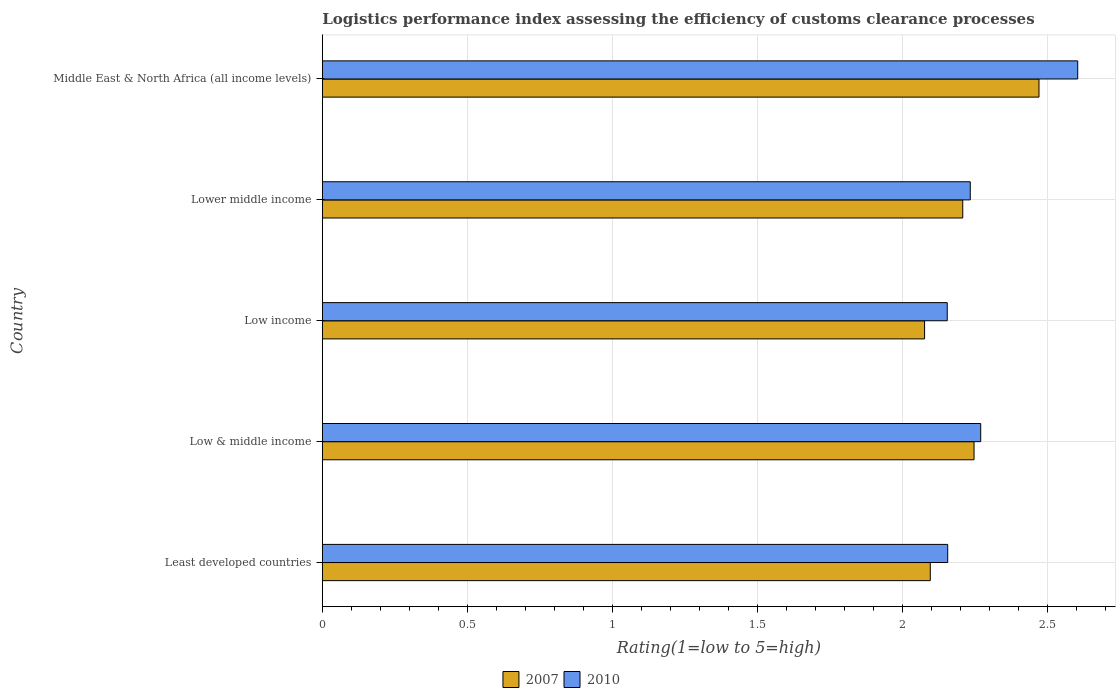How many groups of bars are there?
Offer a terse response. 5. Are the number of bars per tick equal to the number of legend labels?
Keep it short and to the point. Yes. How many bars are there on the 4th tick from the top?
Provide a succinct answer. 2. How many bars are there on the 3rd tick from the bottom?
Offer a terse response. 2. What is the label of the 2nd group of bars from the top?
Provide a succinct answer. Lower middle income. In how many cases, is the number of bars for a given country not equal to the number of legend labels?
Provide a short and direct response. 0. What is the Logistic performance index in 2010 in Low income?
Provide a short and direct response. 2.15. Across all countries, what is the maximum Logistic performance index in 2007?
Provide a short and direct response. 2.47. Across all countries, what is the minimum Logistic performance index in 2007?
Keep it short and to the point. 2.08. In which country was the Logistic performance index in 2007 maximum?
Offer a terse response. Middle East & North Africa (all income levels). In which country was the Logistic performance index in 2010 minimum?
Provide a succinct answer. Low income. What is the total Logistic performance index in 2010 in the graph?
Keep it short and to the point. 11.42. What is the difference between the Logistic performance index in 2007 in Low & middle income and that in Lower middle income?
Your answer should be very brief. 0.04. What is the difference between the Logistic performance index in 2007 in Least developed countries and the Logistic performance index in 2010 in Low & middle income?
Your answer should be very brief. -0.17. What is the average Logistic performance index in 2007 per country?
Ensure brevity in your answer.  2.22. What is the difference between the Logistic performance index in 2010 and Logistic performance index in 2007 in Low & middle income?
Offer a very short reply. 0.02. In how many countries, is the Logistic performance index in 2007 greater than 0.30000000000000004 ?
Your answer should be compact. 5. What is the ratio of the Logistic performance index in 2010 in Low & middle income to that in Low income?
Give a very brief answer. 1.05. Is the difference between the Logistic performance index in 2010 in Low & middle income and Lower middle income greater than the difference between the Logistic performance index in 2007 in Low & middle income and Lower middle income?
Provide a short and direct response. No. What is the difference between the highest and the second highest Logistic performance index in 2007?
Your response must be concise. 0.22. What is the difference between the highest and the lowest Logistic performance index in 2007?
Provide a succinct answer. 0.39. Is the sum of the Logistic performance index in 2010 in Low & middle income and Lower middle income greater than the maximum Logistic performance index in 2007 across all countries?
Your answer should be compact. Yes. What does the 2nd bar from the top in Least developed countries represents?
Your response must be concise. 2007. What does the 1st bar from the bottom in Low income represents?
Provide a succinct answer. 2007. Are the values on the major ticks of X-axis written in scientific E-notation?
Keep it short and to the point. No. Does the graph contain any zero values?
Your response must be concise. No. Where does the legend appear in the graph?
Offer a very short reply. Bottom center. How many legend labels are there?
Your answer should be compact. 2. How are the legend labels stacked?
Keep it short and to the point. Horizontal. What is the title of the graph?
Ensure brevity in your answer.  Logistics performance index assessing the efficiency of customs clearance processes. Does "1980" appear as one of the legend labels in the graph?
Give a very brief answer. No. What is the label or title of the X-axis?
Make the answer very short. Rating(1=low to 5=high). What is the label or title of the Y-axis?
Provide a succinct answer. Country. What is the Rating(1=low to 5=high) in 2007 in Least developed countries?
Your response must be concise. 2.1. What is the Rating(1=low to 5=high) in 2010 in Least developed countries?
Give a very brief answer. 2.16. What is the Rating(1=low to 5=high) in 2007 in Low & middle income?
Keep it short and to the point. 2.25. What is the Rating(1=low to 5=high) in 2010 in Low & middle income?
Offer a terse response. 2.27. What is the Rating(1=low to 5=high) in 2007 in Low income?
Provide a short and direct response. 2.08. What is the Rating(1=low to 5=high) of 2010 in Low income?
Give a very brief answer. 2.15. What is the Rating(1=low to 5=high) of 2007 in Lower middle income?
Offer a terse response. 2.21. What is the Rating(1=low to 5=high) in 2010 in Lower middle income?
Your answer should be compact. 2.23. What is the Rating(1=low to 5=high) of 2007 in Middle East & North Africa (all income levels)?
Offer a terse response. 2.47. What is the Rating(1=low to 5=high) in 2010 in Middle East & North Africa (all income levels)?
Your answer should be compact. 2.6. Across all countries, what is the maximum Rating(1=low to 5=high) of 2007?
Your answer should be compact. 2.47. Across all countries, what is the maximum Rating(1=low to 5=high) of 2010?
Provide a succinct answer. 2.6. Across all countries, what is the minimum Rating(1=low to 5=high) in 2007?
Your answer should be compact. 2.08. Across all countries, what is the minimum Rating(1=low to 5=high) of 2010?
Offer a terse response. 2.15. What is the total Rating(1=low to 5=high) in 2007 in the graph?
Your answer should be compact. 11.1. What is the total Rating(1=low to 5=high) of 2010 in the graph?
Ensure brevity in your answer.  11.42. What is the difference between the Rating(1=low to 5=high) in 2007 in Least developed countries and that in Low & middle income?
Give a very brief answer. -0.15. What is the difference between the Rating(1=low to 5=high) in 2010 in Least developed countries and that in Low & middle income?
Your answer should be very brief. -0.11. What is the difference between the Rating(1=low to 5=high) of 2007 in Least developed countries and that in Low income?
Keep it short and to the point. 0.02. What is the difference between the Rating(1=low to 5=high) of 2010 in Least developed countries and that in Low income?
Make the answer very short. 0. What is the difference between the Rating(1=low to 5=high) in 2007 in Least developed countries and that in Lower middle income?
Make the answer very short. -0.11. What is the difference between the Rating(1=low to 5=high) of 2010 in Least developed countries and that in Lower middle income?
Provide a short and direct response. -0.08. What is the difference between the Rating(1=low to 5=high) in 2007 in Least developed countries and that in Middle East & North Africa (all income levels)?
Provide a succinct answer. -0.37. What is the difference between the Rating(1=low to 5=high) in 2010 in Least developed countries and that in Middle East & North Africa (all income levels)?
Make the answer very short. -0.45. What is the difference between the Rating(1=low to 5=high) of 2007 in Low & middle income and that in Low income?
Give a very brief answer. 0.17. What is the difference between the Rating(1=low to 5=high) of 2010 in Low & middle income and that in Low income?
Your answer should be compact. 0.12. What is the difference between the Rating(1=low to 5=high) in 2007 in Low & middle income and that in Lower middle income?
Provide a short and direct response. 0.04. What is the difference between the Rating(1=low to 5=high) in 2010 in Low & middle income and that in Lower middle income?
Provide a short and direct response. 0.04. What is the difference between the Rating(1=low to 5=high) in 2007 in Low & middle income and that in Middle East & North Africa (all income levels)?
Offer a terse response. -0.22. What is the difference between the Rating(1=low to 5=high) in 2010 in Low & middle income and that in Middle East & North Africa (all income levels)?
Your answer should be compact. -0.33. What is the difference between the Rating(1=low to 5=high) of 2007 in Low income and that in Lower middle income?
Your response must be concise. -0.13. What is the difference between the Rating(1=low to 5=high) in 2010 in Low income and that in Lower middle income?
Your answer should be compact. -0.08. What is the difference between the Rating(1=low to 5=high) of 2007 in Low income and that in Middle East & North Africa (all income levels)?
Give a very brief answer. -0.39. What is the difference between the Rating(1=low to 5=high) of 2010 in Low income and that in Middle East & North Africa (all income levels)?
Offer a terse response. -0.45. What is the difference between the Rating(1=low to 5=high) of 2007 in Lower middle income and that in Middle East & North Africa (all income levels)?
Give a very brief answer. -0.26. What is the difference between the Rating(1=low to 5=high) of 2010 in Lower middle income and that in Middle East & North Africa (all income levels)?
Your response must be concise. -0.37. What is the difference between the Rating(1=low to 5=high) of 2007 in Least developed countries and the Rating(1=low to 5=high) of 2010 in Low & middle income?
Keep it short and to the point. -0.17. What is the difference between the Rating(1=low to 5=high) in 2007 in Least developed countries and the Rating(1=low to 5=high) in 2010 in Low income?
Give a very brief answer. -0.06. What is the difference between the Rating(1=low to 5=high) of 2007 in Least developed countries and the Rating(1=low to 5=high) of 2010 in Lower middle income?
Offer a very short reply. -0.14. What is the difference between the Rating(1=low to 5=high) of 2007 in Least developed countries and the Rating(1=low to 5=high) of 2010 in Middle East & North Africa (all income levels)?
Make the answer very short. -0.51. What is the difference between the Rating(1=low to 5=high) in 2007 in Low & middle income and the Rating(1=low to 5=high) in 2010 in Low income?
Provide a succinct answer. 0.09. What is the difference between the Rating(1=low to 5=high) of 2007 in Low & middle income and the Rating(1=low to 5=high) of 2010 in Lower middle income?
Offer a terse response. 0.01. What is the difference between the Rating(1=low to 5=high) in 2007 in Low & middle income and the Rating(1=low to 5=high) in 2010 in Middle East & North Africa (all income levels)?
Offer a very short reply. -0.36. What is the difference between the Rating(1=low to 5=high) of 2007 in Low income and the Rating(1=low to 5=high) of 2010 in Lower middle income?
Offer a very short reply. -0.16. What is the difference between the Rating(1=low to 5=high) of 2007 in Low income and the Rating(1=low to 5=high) of 2010 in Middle East & North Africa (all income levels)?
Provide a short and direct response. -0.53. What is the difference between the Rating(1=low to 5=high) of 2007 in Lower middle income and the Rating(1=low to 5=high) of 2010 in Middle East & North Africa (all income levels)?
Your response must be concise. -0.4. What is the average Rating(1=low to 5=high) in 2007 per country?
Give a very brief answer. 2.22. What is the average Rating(1=low to 5=high) in 2010 per country?
Your answer should be very brief. 2.28. What is the difference between the Rating(1=low to 5=high) of 2007 and Rating(1=low to 5=high) of 2010 in Least developed countries?
Make the answer very short. -0.06. What is the difference between the Rating(1=low to 5=high) in 2007 and Rating(1=low to 5=high) in 2010 in Low & middle income?
Offer a terse response. -0.02. What is the difference between the Rating(1=low to 5=high) of 2007 and Rating(1=low to 5=high) of 2010 in Low income?
Ensure brevity in your answer.  -0.08. What is the difference between the Rating(1=low to 5=high) of 2007 and Rating(1=low to 5=high) of 2010 in Lower middle income?
Your response must be concise. -0.03. What is the difference between the Rating(1=low to 5=high) in 2007 and Rating(1=low to 5=high) in 2010 in Middle East & North Africa (all income levels)?
Keep it short and to the point. -0.13. What is the ratio of the Rating(1=low to 5=high) in 2007 in Least developed countries to that in Low & middle income?
Keep it short and to the point. 0.93. What is the ratio of the Rating(1=low to 5=high) in 2010 in Least developed countries to that in Low & middle income?
Provide a succinct answer. 0.95. What is the ratio of the Rating(1=low to 5=high) in 2007 in Least developed countries to that in Low income?
Your answer should be compact. 1.01. What is the ratio of the Rating(1=low to 5=high) of 2007 in Least developed countries to that in Lower middle income?
Offer a very short reply. 0.95. What is the ratio of the Rating(1=low to 5=high) in 2010 in Least developed countries to that in Lower middle income?
Offer a very short reply. 0.97. What is the ratio of the Rating(1=low to 5=high) of 2007 in Least developed countries to that in Middle East & North Africa (all income levels)?
Your answer should be compact. 0.85. What is the ratio of the Rating(1=low to 5=high) in 2010 in Least developed countries to that in Middle East & North Africa (all income levels)?
Your response must be concise. 0.83. What is the ratio of the Rating(1=low to 5=high) in 2007 in Low & middle income to that in Low income?
Offer a terse response. 1.08. What is the ratio of the Rating(1=low to 5=high) in 2010 in Low & middle income to that in Low income?
Keep it short and to the point. 1.05. What is the ratio of the Rating(1=low to 5=high) of 2007 in Low & middle income to that in Lower middle income?
Your response must be concise. 1.02. What is the ratio of the Rating(1=low to 5=high) of 2010 in Low & middle income to that in Lower middle income?
Ensure brevity in your answer.  1.02. What is the ratio of the Rating(1=low to 5=high) of 2007 in Low & middle income to that in Middle East & North Africa (all income levels)?
Ensure brevity in your answer.  0.91. What is the ratio of the Rating(1=low to 5=high) in 2010 in Low & middle income to that in Middle East & North Africa (all income levels)?
Offer a very short reply. 0.87. What is the ratio of the Rating(1=low to 5=high) of 2007 in Low income to that in Lower middle income?
Offer a very short reply. 0.94. What is the ratio of the Rating(1=low to 5=high) in 2010 in Low income to that in Lower middle income?
Offer a terse response. 0.96. What is the ratio of the Rating(1=low to 5=high) of 2007 in Low income to that in Middle East & North Africa (all income levels)?
Offer a very short reply. 0.84. What is the ratio of the Rating(1=low to 5=high) in 2010 in Low income to that in Middle East & North Africa (all income levels)?
Provide a succinct answer. 0.83. What is the ratio of the Rating(1=low to 5=high) in 2007 in Lower middle income to that in Middle East & North Africa (all income levels)?
Ensure brevity in your answer.  0.89. What is the ratio of the Rating(1=low to 5=high) in 2010 in Lower middle income to that in Middle East & North Africa (all income levels)?
Give a very brief answer. 0.86. What is the difference between the highest and the second highest Rating(1=low to 5=high) of 2007?
Your response must be concise. 0.22. What is the difference between the highest and the second highest Rating(1=low to 5=high) in 2010?
Offer a terse response. 0.33. What is the difference between the highest and the lowest Rating(1=low to 5=high) in 2007?
Provide a short and direct response. 0.39. What is the difference between the highest and the lowest Rating(1=low to 5=high) of 2010?
Your response must be concise. 0.45. 